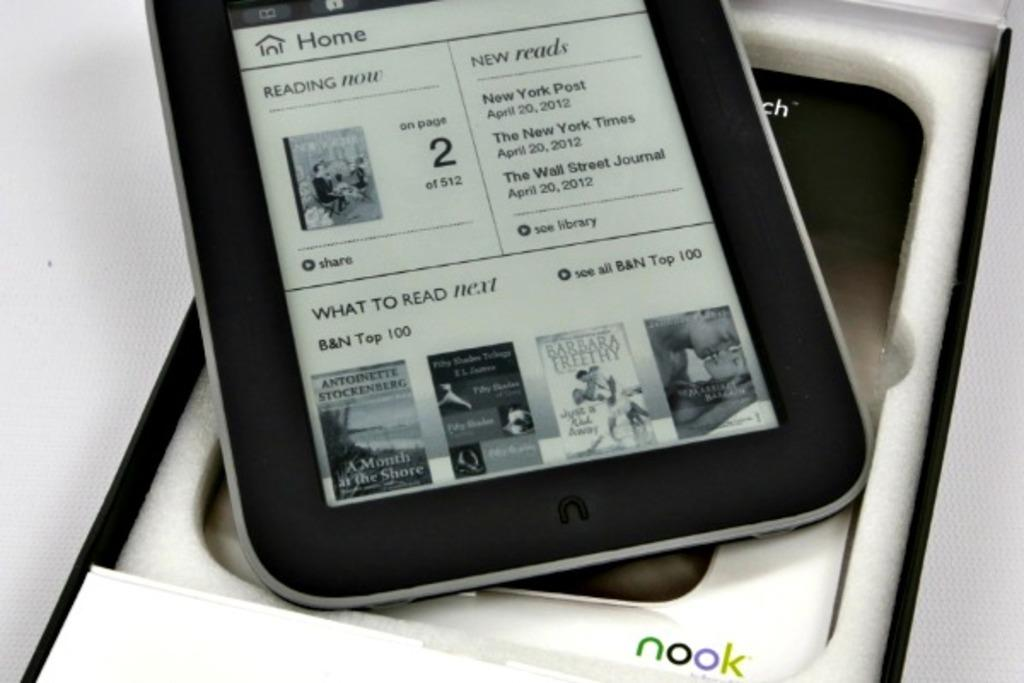What object can be seen in the image? There is a mobile in the image. Where is the mobile located? The mobile is placed on a table. Is there a fire hydrant next to the mobile in the image? No, there is no fire hydrant present in the image. Can you see anyone joining the mobile in the image? No, there are no people or other objects joining the mobile in the image. 